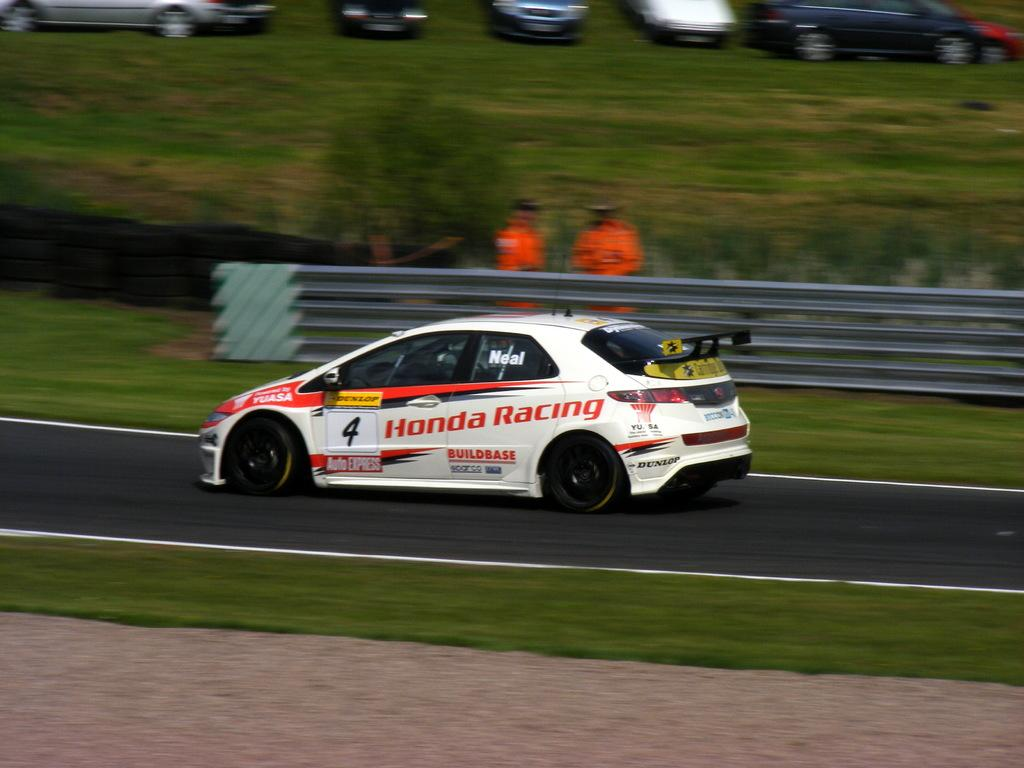<image>
Describe the image concisely. A white Honda Racing car is driving around a race track. 